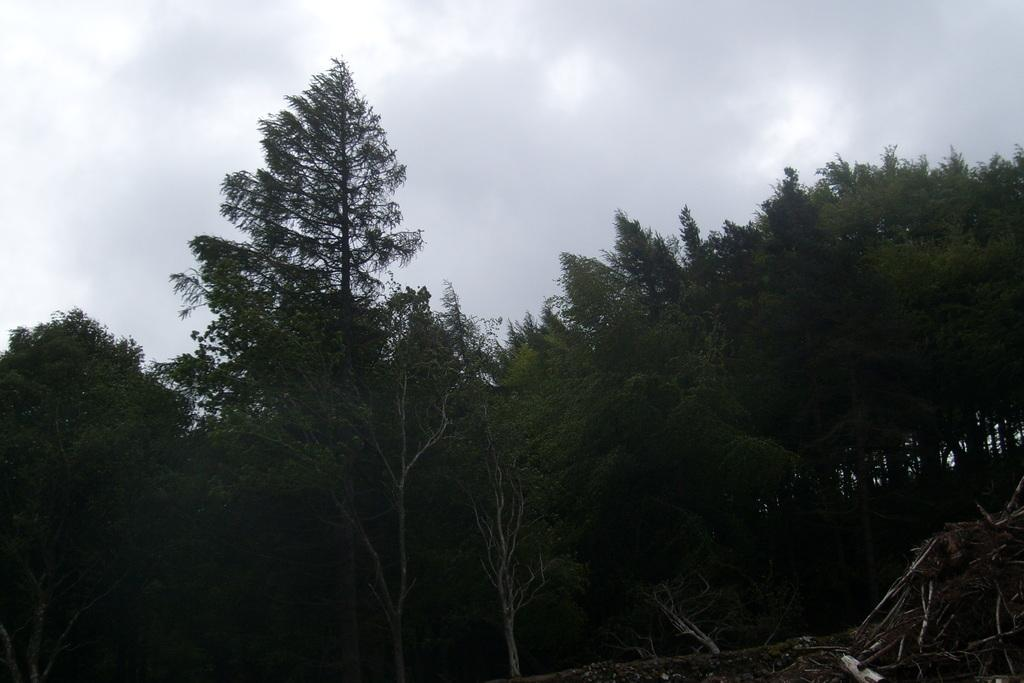What type of vegetation can be seen in the image? There are trees in the image. What is visible in the background of the image? The sky is visible in the image. What can be observed in the sky in the image? Clouds are present in the image. How many frogs can be seen sitting on the apple in the image? There is no apple or frogs present in the image. 